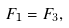<formula> <loc_0><loc_0><loc_500><loc_500>F _ { 1 } = F _ { 3 } ,</formula> 